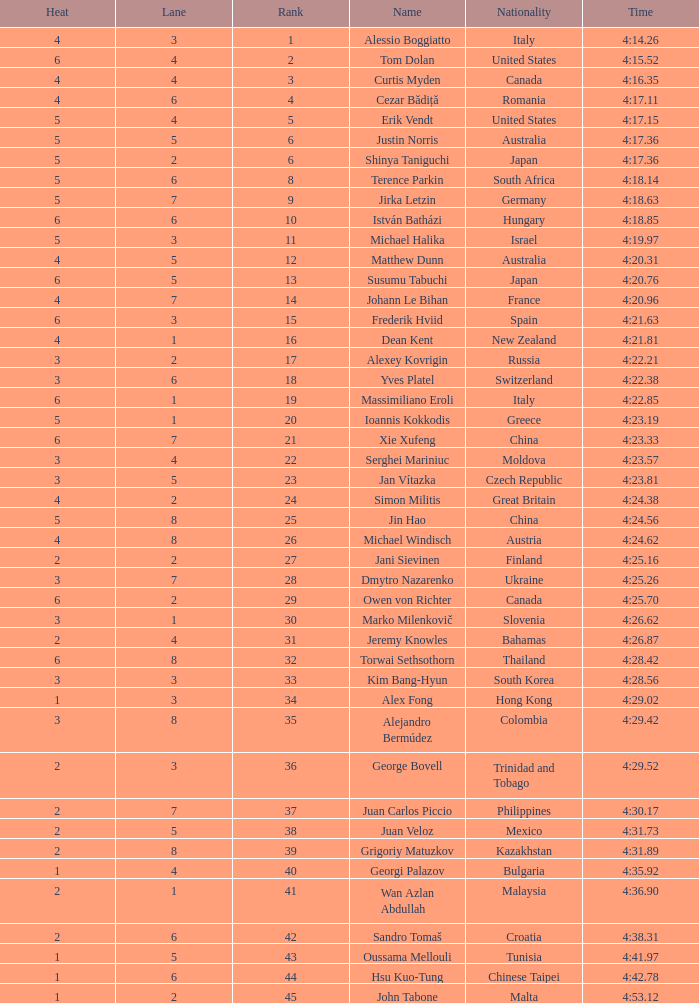Who was the 4 lane person from Canada? 4.0. 